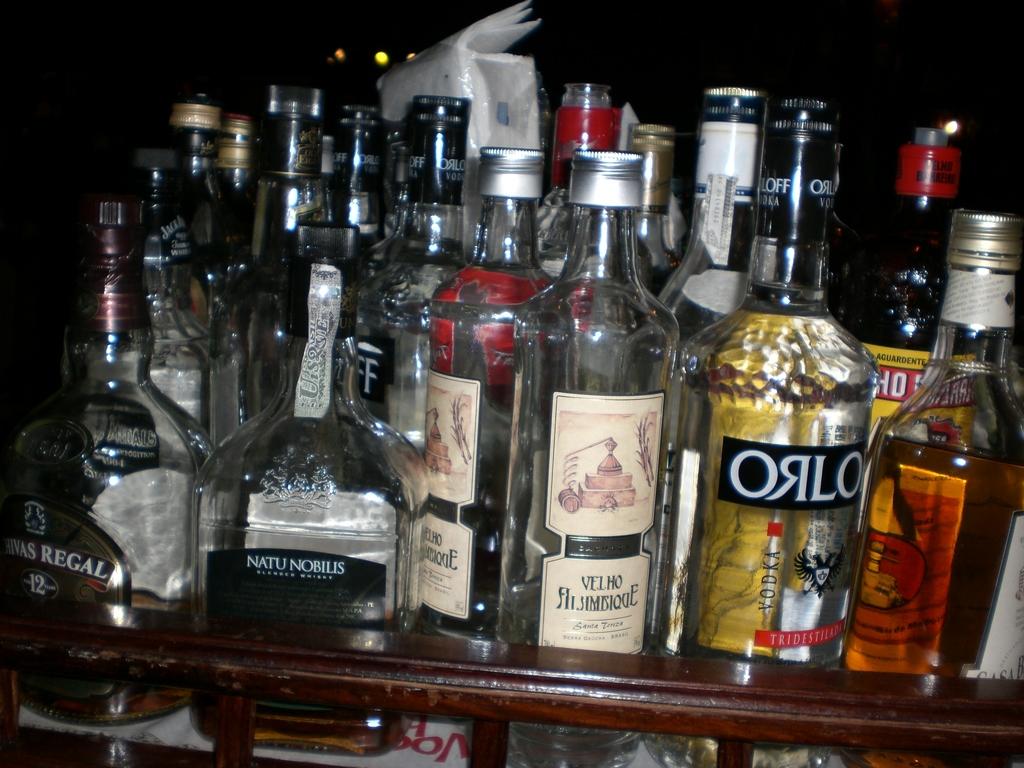What brand is shown at the far left?
Your answer should be very brief. Regal. This is a alchocal?
Ensure brevity in your answer.  Yes. 